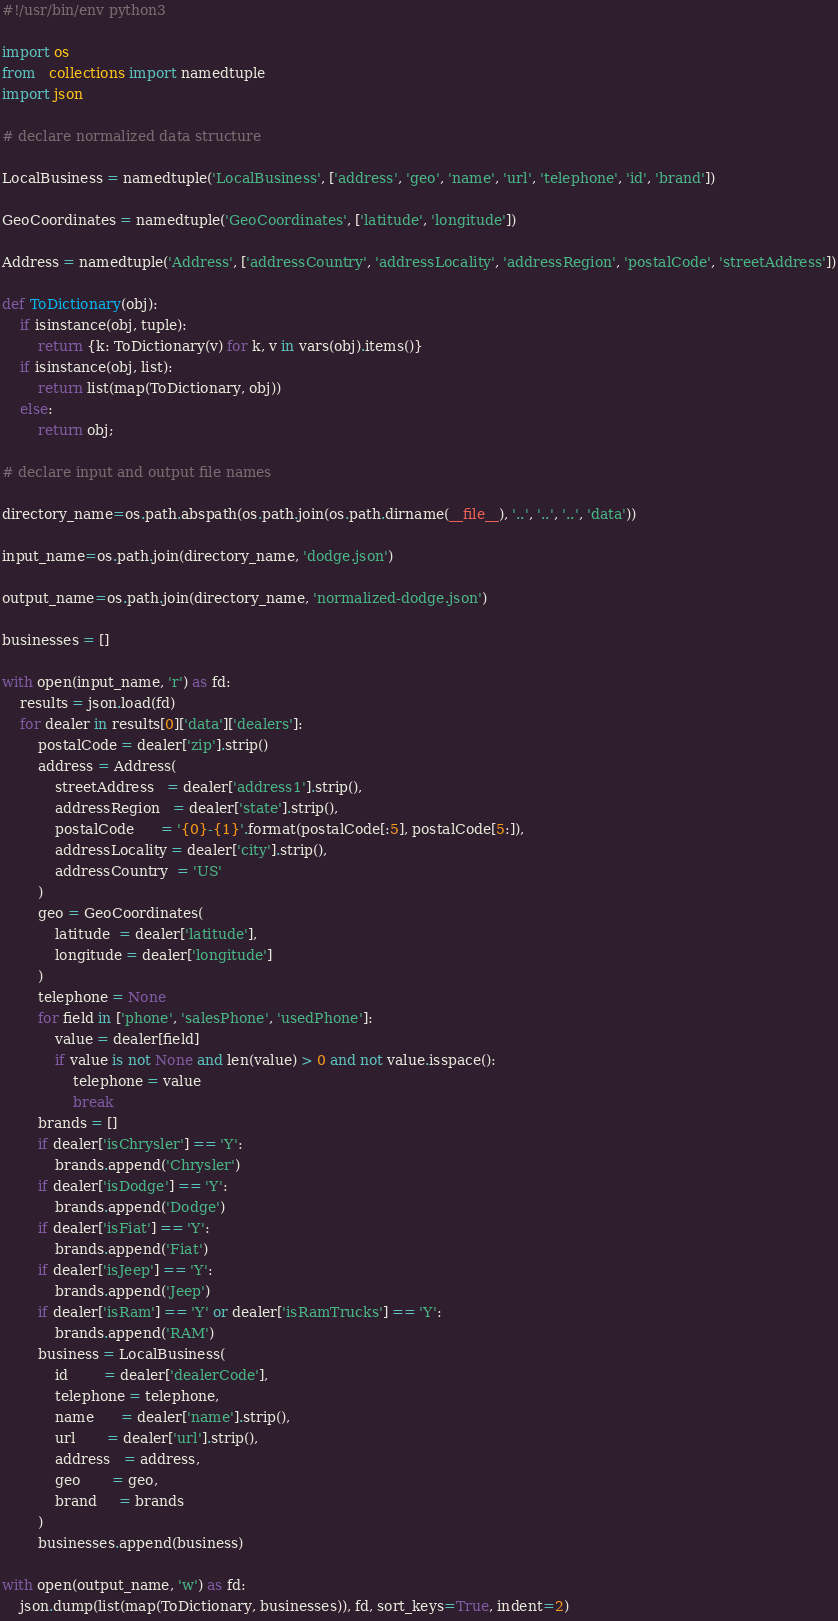Convert code to text. <code><loc_0><loc_0><loc_500><loc_500><_Python_>#!/usr/bin/env python3

import os
from   collections import namedtuple
import json

# declare normalized data structure

LocalBusiness = namedtuple('LocalBusiness', ['address', 'geo', 'name', 'url', 'telephone', 'id', 'brand'])

GeoCoordinates = namedtuple('GeoCoordinates', ['latitude', 'longitude'])

Address = namedtuple('Address', ['addressCountry', 'addressLocality', 'addressRegion', 'postalCode', 'streetAddress'])

def ToDictionary(obj):
    if isinstance(obj, tuple):
        return {k: ToDictionary(v) for k, v in vars(obj).items()}
    if isinstance(obj, list):
        return list(map(ToDictionary, obj))
    else:
        return obj;

# declare input and output file names

directory_name=os.path.abspath(os.path.join(os.path.dirname(__file__), '..', '..', '..', 'data'))

input_name=os.path.join(directory_name, 'dodge.json')

output_name=os.path.join(directory_name, 'normalized-dodge.json')

businesses = []

with open(input_name, 'r') as fd:
    results = json.load(fd)
    for dealer in results[0]['data']['dealers']:
        postalCode = dealer['zip'].strip()
        address = Address(
            streetAddress   = dealer['address1'].strip(),
            addressRegion   = dealer['state'].strip(),
            postalCode      = '{0}-{1}'.format(postalCode[:5], postalCode[5:]),
            addressLocality = dealer['city'].strip(),
            addressCountry  = 'US'
        )
        geo = GeoCoordinates(
            latitude  = dealer['latitude'],
            longitude = dealer['longitude']
        )
        telephone = None
        for field in ['phone', 'salesPhone', 'usedPhone']:
            value = dealer[field]
            if value is not None and len(value) > 0 and not value.isspace():
                telephone = value
                break
        brands = []
        if dealer['isChrysler'] == 'Y':
            brands.append('Chrysler')
        if dealer['isDodge'] == 'Y':
            brands.append('Dodge')
        if dealer['isFiat'] == 'Y':
            brands.append('Fiat')
        if dealer['isJeep'] == 'Y':
            brands.append('Jeep')
        if dealer['isRam'] == 'Y' or dealer['isRamTrucks'] == 'Y':
            brands.append('RAM')
        business = LocalBusiness(
            id        = dealer['dealerCode'],
            telephone = telephone,
            name      = dealer['name'].strip(),
            url       = dealer['url'].strip(),
            address   = address,
            geo       = geo,
            brand     = brands
        )
        businesses.append(business)

with open(output_name, 'w') as fd:
    json.dump(list(map(ToDictionary, businesses)), fd, sort_keys=True, indent=2)

</code> 